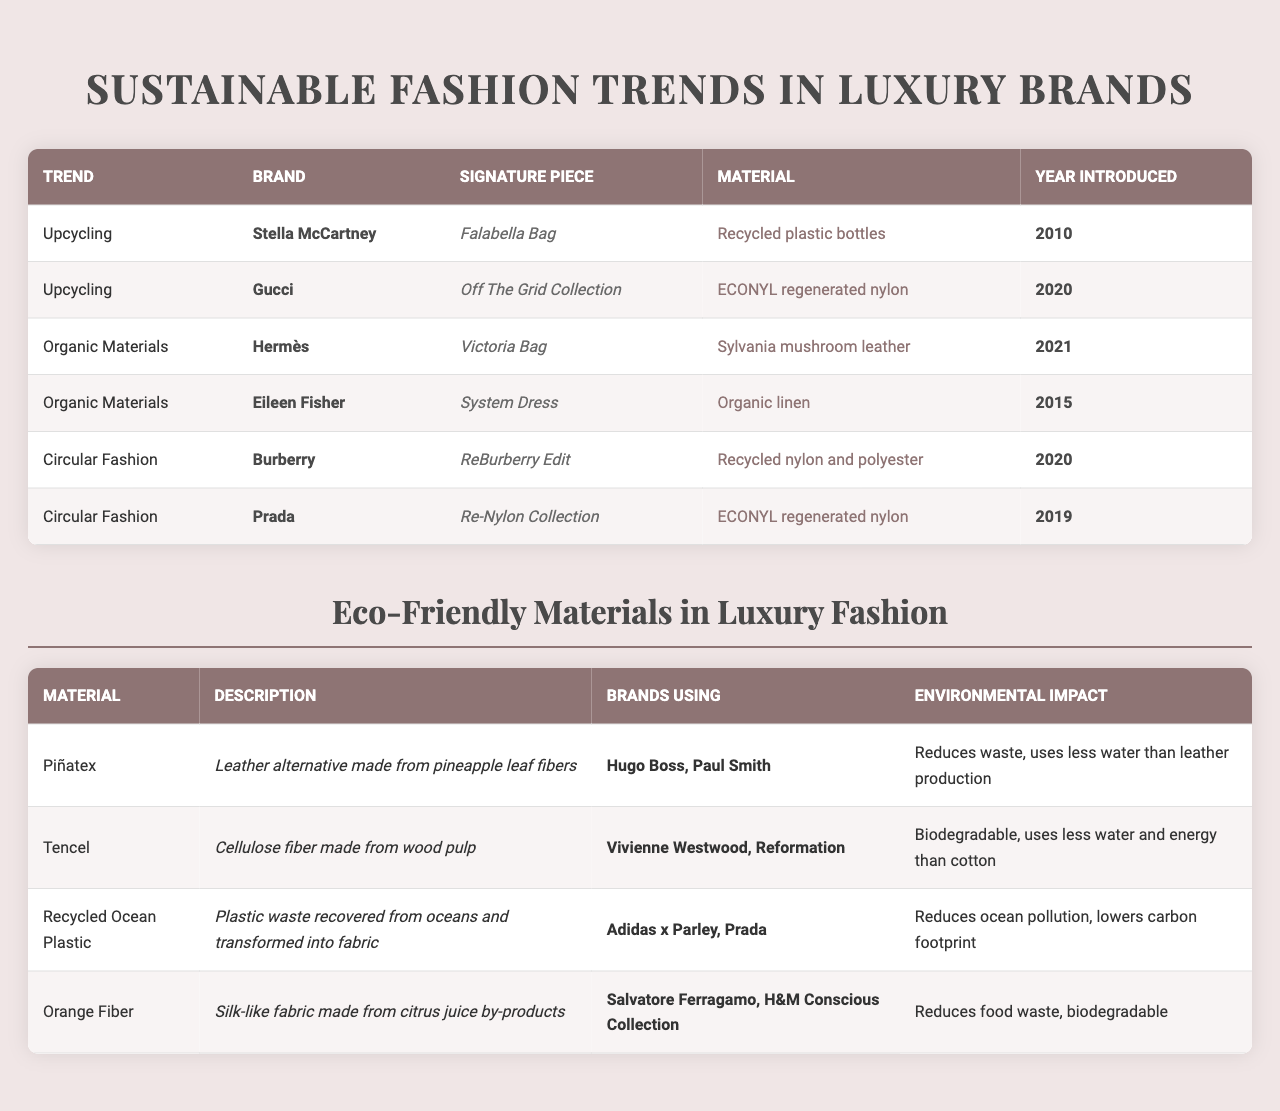What are the signature pieces associated with upcycling trends? The table lists the brands under the upcycling trend and their corresponding signature pieces. Stella McCartney’s signature piece is the "Falabella Bag," and Gucci’s is the "Off The Grid Collection."
Answer: Falabella Bag, Off The Grid Collection Which luxury brand introduced a product using Sylvania mushroom leather? The table indicates that Hermès introduced the Victoria Bag, which is made from Sylvania mushroom leather.
Answer: Hermès What materials are used in the Re-Nylon Collection by Prada? The data cites that Prada’s Re-Nylon Collection uses ECONYL regenerated nylon.
Answer: ECONYL regenerated nylon How many brands are associated with the use of Piñatex? From the table, Piñatex is associated with Hugo Boss and Paul Smith, totaling two brands.
Answer: 2 Is there a signature piece introduced by a brand in the year 2021? The table shows that Hermès introduced the Victoria Bag in 2021, confirming that there is a signature piece from that year.
Answer: Yes What is the environmental impact of using Tencel? The table describes Tencel as biodegradable and notes that it uses less water and energy than cotton.
Answer: Biodegradable, less water and energy than cotton Which trend has the most brands listed? By counting the brands under each trend, Upcycling has two brands (Stella McCartney and Gucci), Organic Materials has two brands (Hermès and Eileen Fisher), and Circular Fashion also has two brands (Burberry and Prada). Thus, all trends have equal representation with two brands each.
Answer: All have equal representation: 2 brands What year was the first brand in the Circular Fashion trend introduced? The first listed brand under Circular Fashion is Burberry, which introduced the ReBurberry Edit in 2020.
Answer: 2020 What is the common material used between Burberry and Prada? Both brands in the Circular Fashion trend utilize recycled materials; Burberry uses recycled nylon and polyester, while Prada uses ECONYL regenerated nylon.
Answer: Both use recycled materials Which material is both biodegradable and made from citrus juice by-products? The table specifies that Orange Fiber is a silk-like fabric made from citrus juice by-products and is biodegradable as well.
Answer: Orange Fiber 